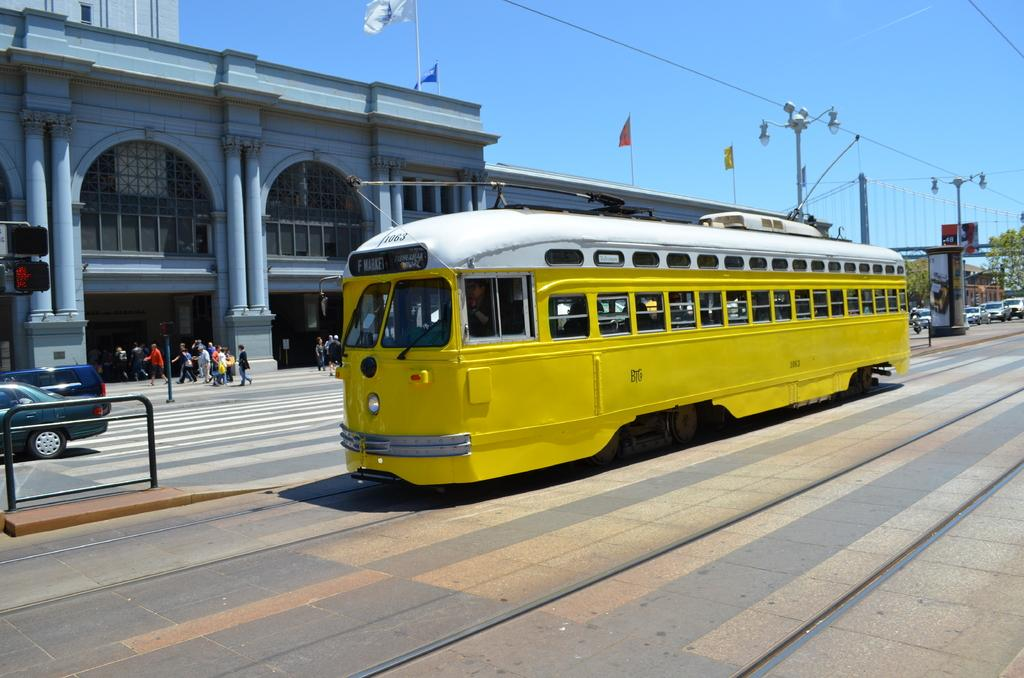What is the main subject of the image? The main subject of the image is a train on the railway track. What else can be seen in the image besides the train? There are buildings, a group of people, vehicles on the road, flags with poles, lights, trees, and the sky visible in the background. What type of screw can be seen holding the train together in the image? There are no screws visible in the image; it is a photograph of a train on a railway track. What is the texture of the nerve fibers in the image? There are no nerve fibers present in the image; it is a photograph of a train on a railway track. 